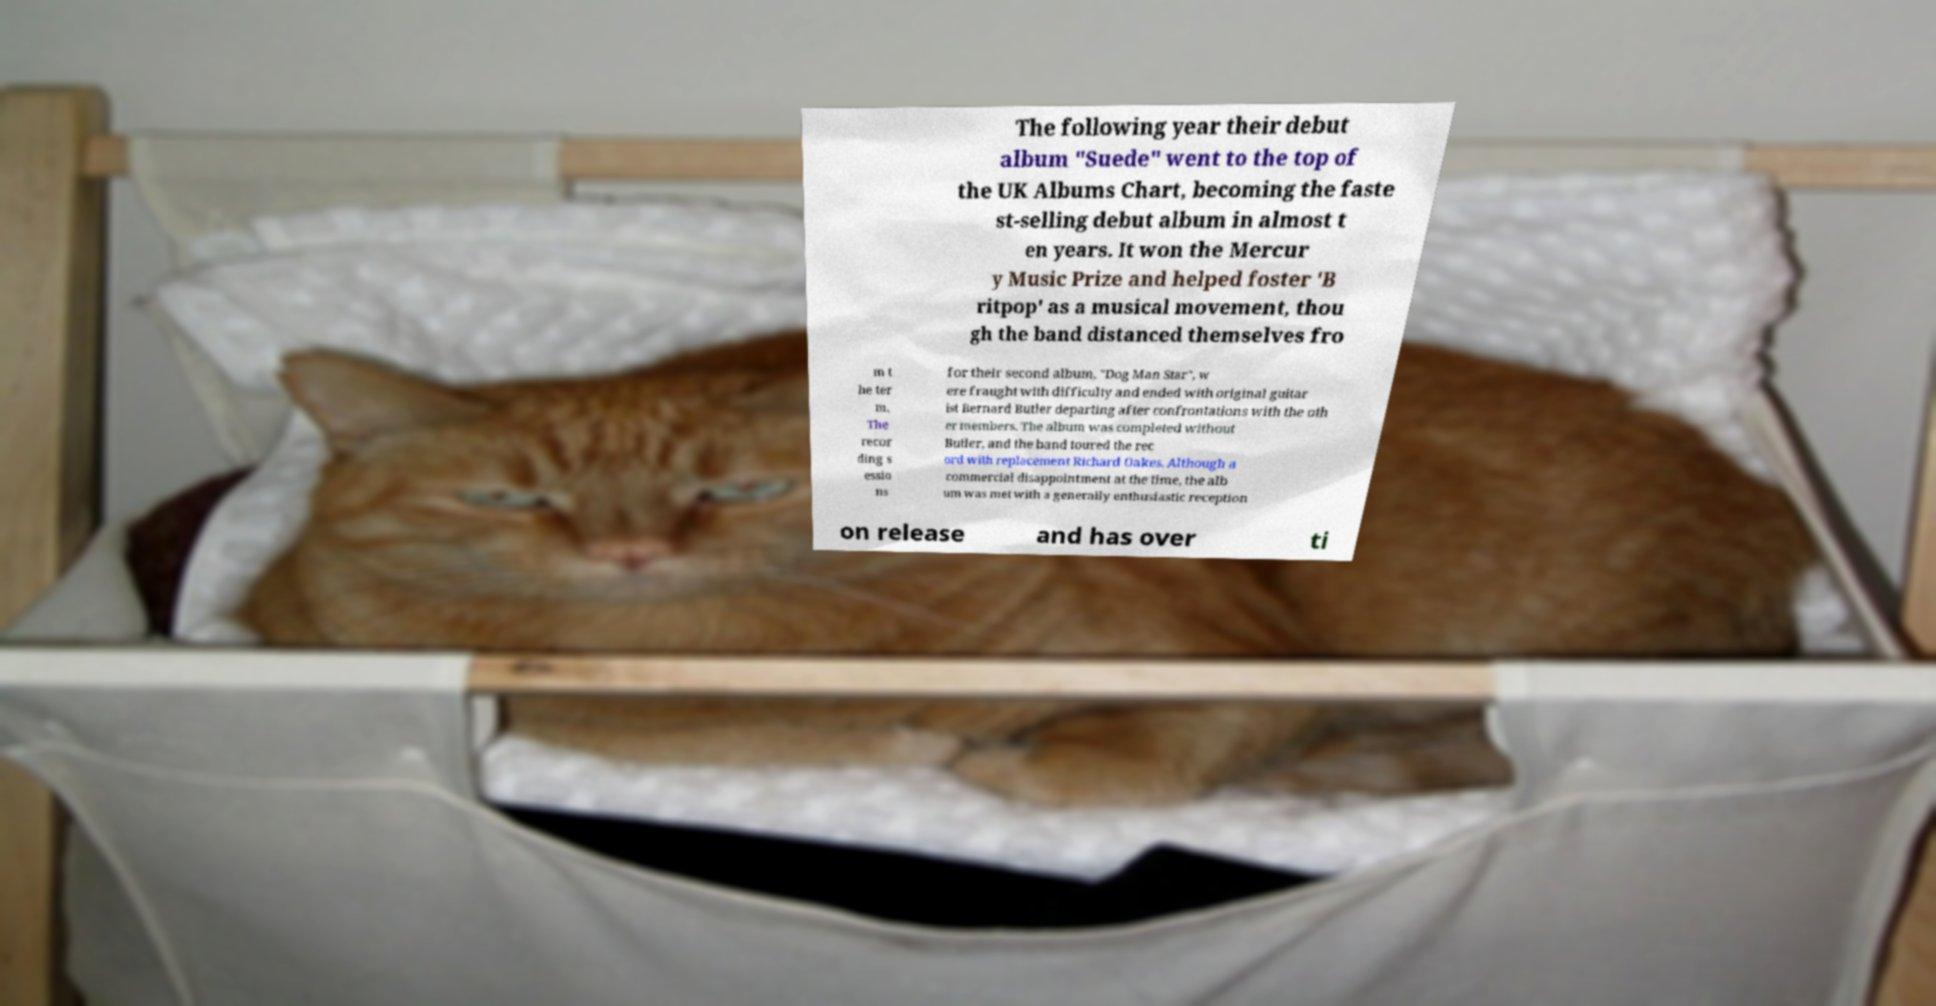What messages or text are displayed in this image? I need them in a readable, typed format. The following year their debut album "Suede" went to the top of the UK Albums Chart, becoming the faste st-selling debut album in almost t en years. It won the Mercur y Music Prize and helped foster 'B ritpop' as a musical movement, thou gh the band distanced themselves fro m t he ter m. The recor ding s essio ns for their second album, "Dog Man Star", w ere fraught with difficulty and ended with original guitar ist Bernard Butler departing after confrontations with the oth er members. The album was completed without Butler, and the band toured the rec ord with replacement Richard Oakes. Although a commercial disappointment at the time, the alb um was met with a generally enthusiastic reception on release and has over ti 